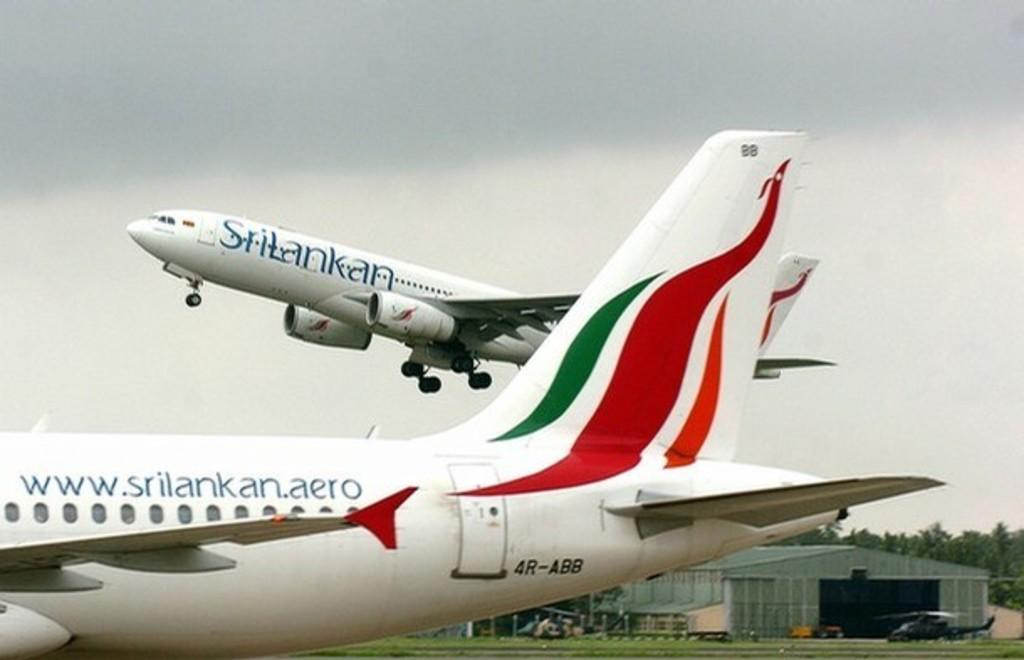Provide a one-sentence caption for the provided image. A srilankan jet is sitting on a runway while another plane is taking off. 